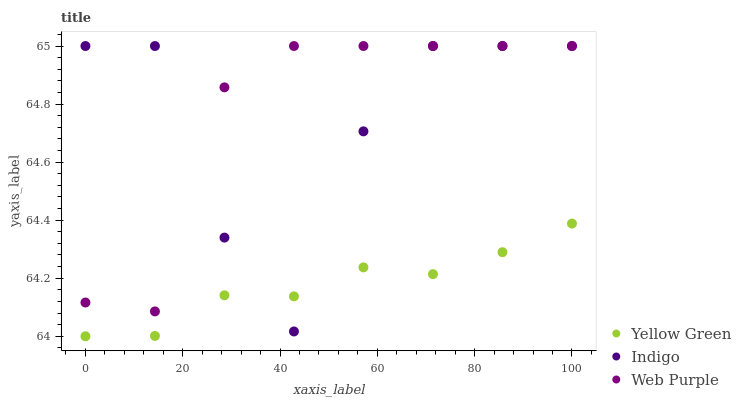Does Yellow Green have the minimum area under the curve?
Answer yes or no. Yes. Does Web Purple have the maximum area under the curve?
Answer yes or no. Yes. Does Indigo have the minimum area under the curve?
Answer yes or no. No. Does Indigo have the maximum area under the curve?
Answer yes or no. No. Is Yellow Green the smoothest?
Answer yes or no. Yes. Is Indigo the roughest?
Answer yes or no. Yes. Is Indigo the smoothest?
Answer yes or no. No. Is Yellow Green the roughest?
Answer yes or no. No. Does Yellow Green have the lowest value?
Answer yes or no. Yes. Does Indigo have the lowest value?
Answer yes or no. No. Does Indigo have the highest value?
Answer yes or no. Yes. Does Yellow Green have the highest value?
Answer yes or no. No. Is Yellow Green less than Web Purple?
Answer yes or no. Yes. Is Web Purple greater than Yellow Green?
Answer yes or no. Yes. Does Indigo intersect Yellow Green?
Answer yes or no. Yes. Is Indigo less than Yellow Green?
Answer yes or no. No. Is Indigo greater than Yellow Green?
Answer yes or no. No. Does Yellow Green intersect Web Purple?
Answer yes or no. No. 